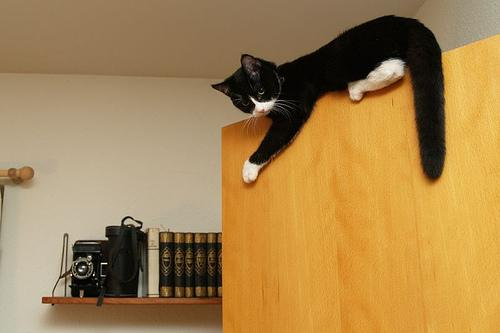In the image, mention the key objects and how they are arranged. A cat perched on a door, a bookshelf with books and an antique camera, and a light brown door are the key objects, with the shelf attached to the wall and the cat on the door. Describe what the main character in this image is doing and what surrounds them. A black and white cat with a long tail and white paws is sitting atop a light brown door, surrounded by a bookshelf filled with books and an antique camera. Examine the objects on the shelf and explain their arrangement and appearance. The shelf holds some books arranged in an organized manner, with black and gold bindings, a white book, and an old-fashion black and silver camera with its carrying case nearby. Elaborate on the location of a certain object in the picture and the objects near it. The antique style camera is placed on a shelf next to some books, having a carrying case on one side and a white book on the other. Talk about the main action happening in this picture and any significant details associated with it. A black and white cat is sitting on top of a door, looking down, with its long black tail, white paws, and white whiskers being noticeable features. Please detail the various colors and shapes of objects present in this image. Colors include black and white for the cat, light brown for the door, beige for the wall, black and gold for book bindings, and black and silver for the antique camera. Shapes include the rectangular door, bookshelf, and books, and the round wooden end of a curtain rod. Identify the primary figure in the image and describe their appearance and actions. The image features a black and white cat sitting on top of a light brown door, with its pointed forward ears, white whiskers, and white paws visible. Please describe the scene in this picture, focusing on the key elements and their positions. The scene displays a cat perched on top of a door, a wooden bookshelf attached to a beige wall filled with various books, including some with black and gold bindings, and an antique style camera. Tell me what the most prominent animal is doing in the picture, and point out any distinguishing features. The most prominent animal, a black and white cat, is peacefully sitting on top of a door, setting itself apart with pointy ears, long black tail, white paws, and white whiskers. What is the main animal that can be seen in this image and discuss the unique features of this animal? The main animal is a black and white cat with white paws, pointed forward ears, and white whiskers, sitting on top of a door. Does the cat with blue eyes sit near the window? There is no information provided about the cat's eye color or its proximity to a window. The cat is described as sitting on top of a door. Segment the objects and areas inside the image. object 1: shelf; object 2: books; object 3: camera; object 4: door; object 5: cat; object 6: knob; object 7: curtain rod; object 8: carrying case Analyze the interaction between the cat and the door. The cat is passively interacting with the door by sitting on top of it, looking down, and feeling secured by its height. Find a small potted plant placed beside the camera. There is no mention of a potted plant in the image. A blue metal chair is leaning against the wall beside the shelf. There is no mention of a blue metal chair in the image. Evaluate the overall quality and composition of the image. The image is well-composed with clear object representation and a good balance of elements, presenting a pleasant scene. What is the color of the books' bindings? black and gold, white What is the wooden object with a rounded end? the round wooden end of a curtain rod Detect any unusual or unexpected elements in the image. There are no significant anomalies detected in the image. Count how many black and gold book bindings are there in the image. 6 Observe the purple teddy bear positioned on the shelf. There is no mention of a purple teddy bear in the image. The objects on the shelf are books and an antique-style camera. The red-colored bookshelf is mounted on a dark green wall. There is no mention of a red-colored bookshelf or a dark green wall. The bookshelf is described as wooden, and the wall is beige. Spot the cat holding a toy in its mouth. There is no information about the cat holding a toy in its mouth. The cat is described as sitting on top of the door and looking down. Describe the cat in the image. A black and white cat with pointed ears, white whiskers, a long black tail, and white paws is sitting on top of a light brown door. What is the cat's position within the image? The cat is sitting on top of a door. Can you identify any text or information from the bindings of the books? No visible text or information available from the book bindings. The green and yellow striped curtains hang next to the bookshelf. There's no mention of green and yellow striped curtains in the image; the only curtain rod mentioned has a round wooden end. What is next to the antique-style camera on the shelf? books Is the television mounted on the wall near the door? There is no mention of a television in the image. What is unique about the camera on the shelf? It is an old-fashioned black and silver camera, possibly an antique style. Describe the sentiment or emotion conveyed by the image. The image conveys a sense of tranquility and comfort, as the cat rests peacefully atop the door. A brown dog is standing next to the cat on the door. There is no mention of a dog in the image, only a cat sitting on top of a door. Identify objects in the image. books, shelf, cat, door, camera, knob, curtain rod, carrying case What type of camera is on the shelf? old-fashioned black and silver camera Which object would most likely be used by the cat to climb up to its current position? The door. What is the color of the door and the wall in the image? The door is light brown, and the wall is beige. Are the books arranged in any particular manner? Yes, the books are organized. The pink wallpaper against the wall around the door. There's no mention of pink wallpaper or any wallpaper; the wall is described as beige. Is there an object in the image that is closely related to the antique camera? Yes, a carrying case for the antique-style camera. Is the cat looking at the camera or down towards the objects on the shelf? The cat is looking down. 